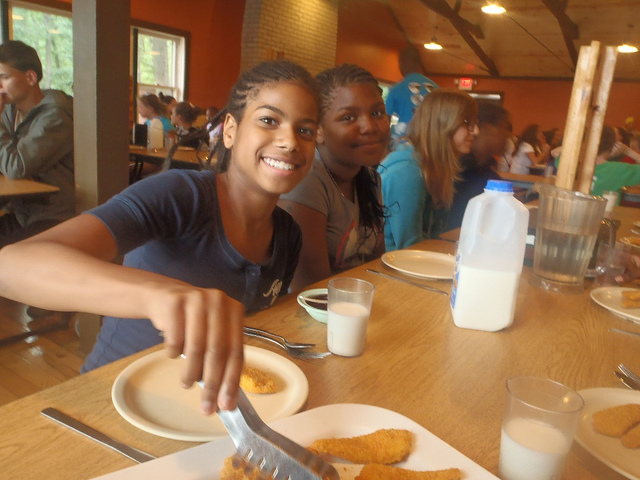<image>What is she eating? I am not sure what she is eating, it could be fish or chicken strips. What is she eating? I am not sure what she is eating. It can be fish, chicken strips, chicken tender, or chicken nuggets. 